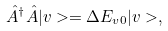<formula> <loc_0><loc_0><loc_500><loc_500>\hat { A } ^ { \dag } \hat { A } | v > = \Delta E _ { v 0 } | v > ,</formula> 